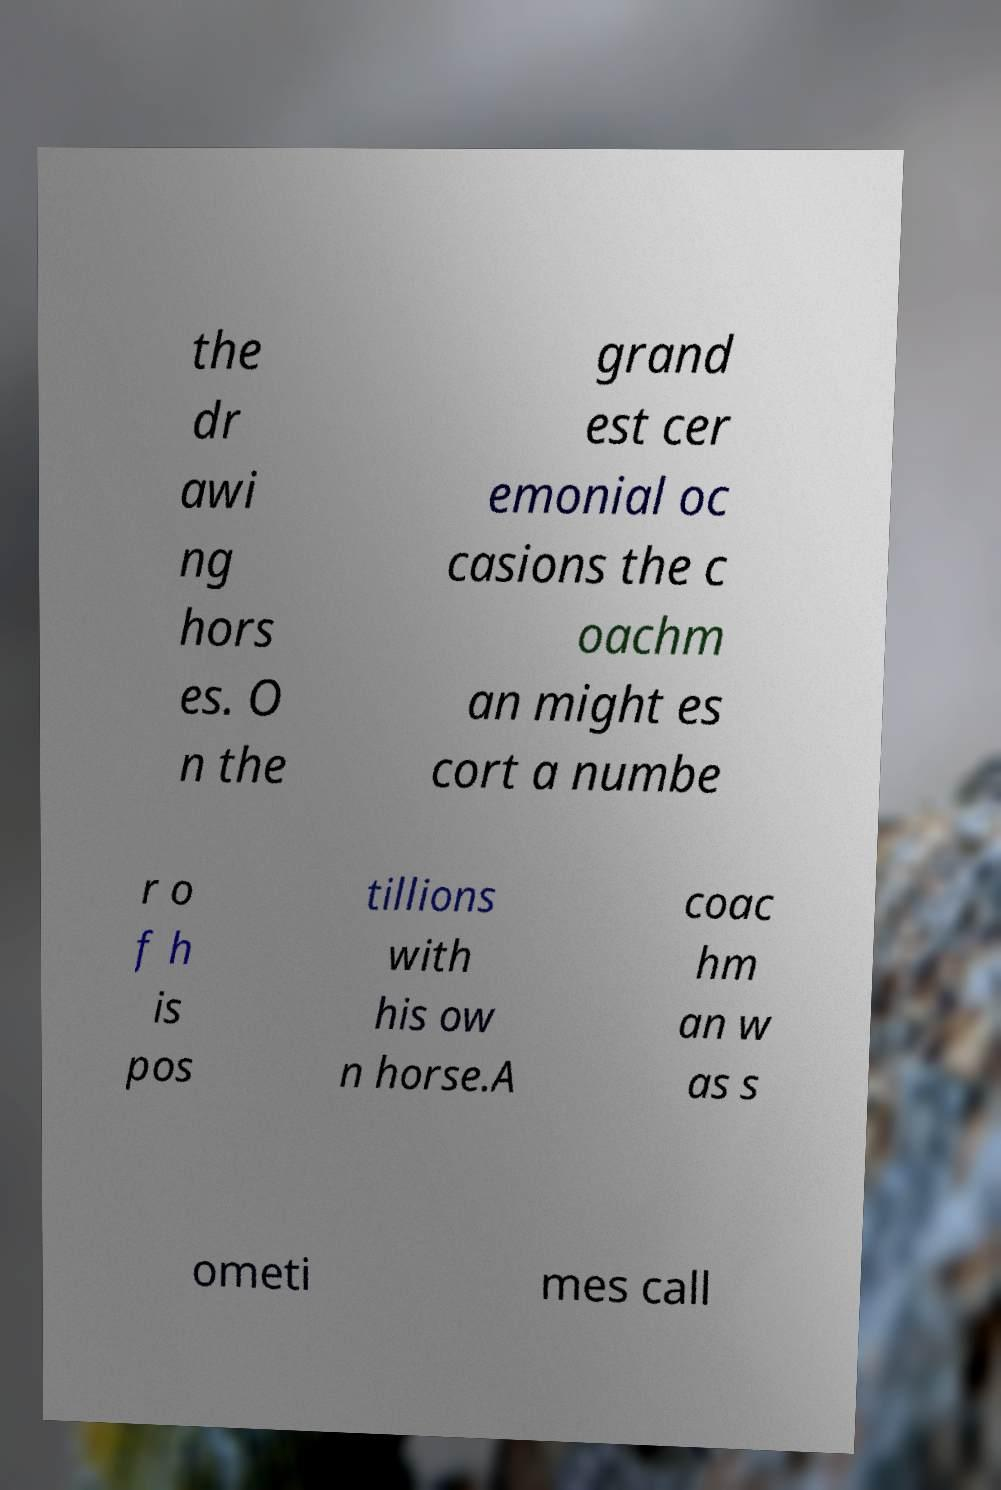Please identify and transcribe the text found in this image. the dr awi ng hors es. O n the grand est cer emonial oc casions the c oachm an might es cort a numbe r o f h is pos tillions with his ow n horse.A coac hm an w as s ometi mes call 